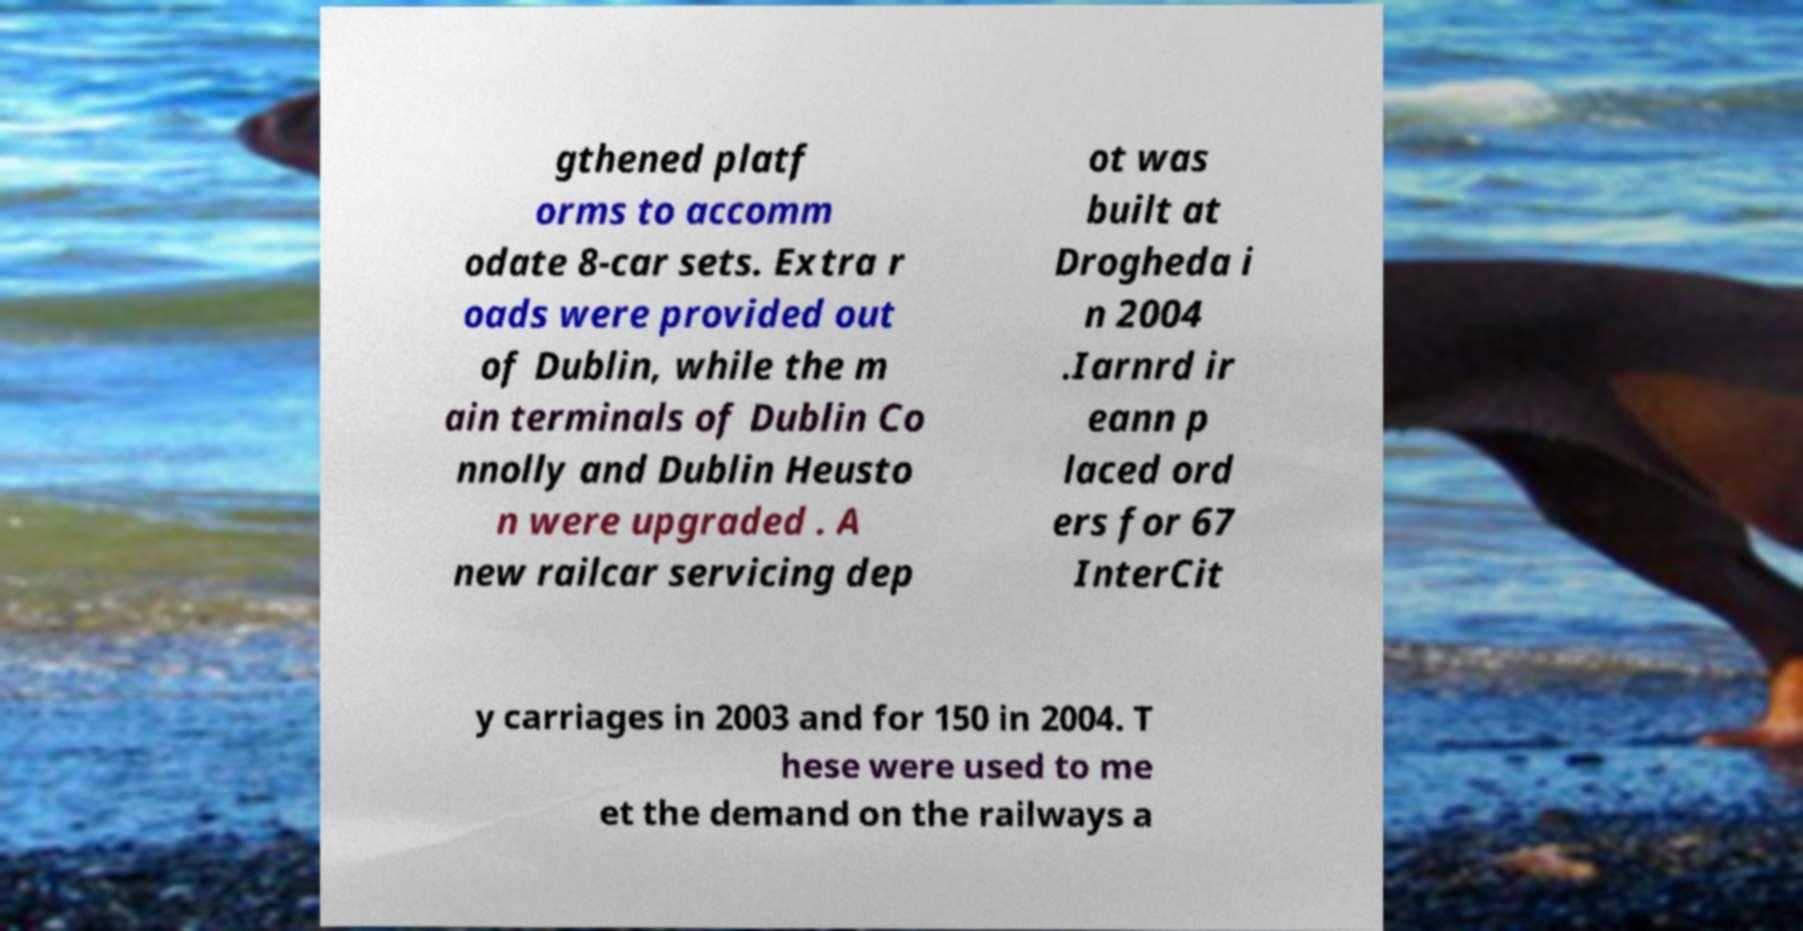Can you accurately transcribe the text from the provided image for me? gthened platf orms to accomm odate 8-car sets. Extra r oads were provided out of Dublin, while the m ain terminals of Dublin Co nnolly and Dublin Heusto n were upgraded . A new railcar servicing dep ot was built at Drogheda i n 2004 .Iarnrd ir eann p laced ord ers for 67 InterCit y carriages in 2003 and for 150 in 2004. T hese were used to me et the demand on the railways a 